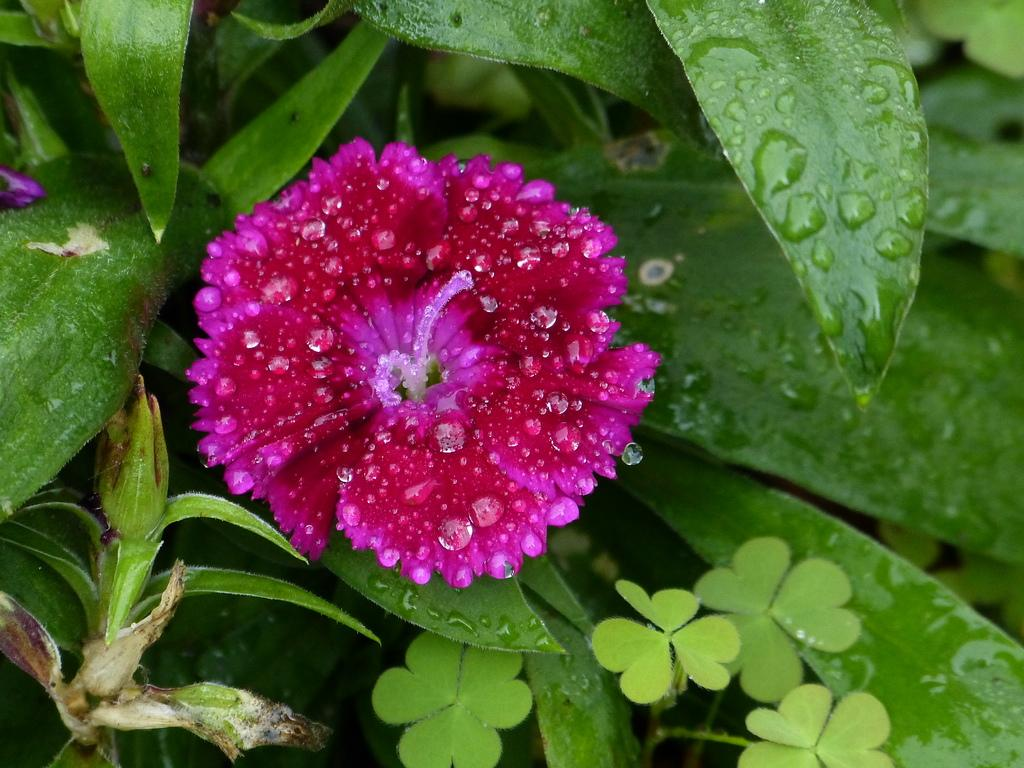What type of flower is in the image? There is a pink flower in the image. What is the flower attached to? The flower is part of a plant. What can be seen around the flower? There are long leaves surrounding the flower. What nation is the girl from, who is standing next to the cow in the image? There is no girl or cow present in the image; it only features a pink flower and its surrounding leaves. 